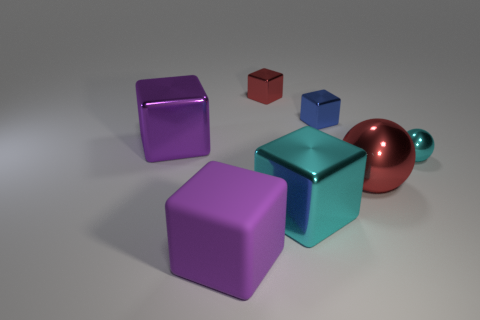Are there fewer small green matte objects than purple matte things? yes 